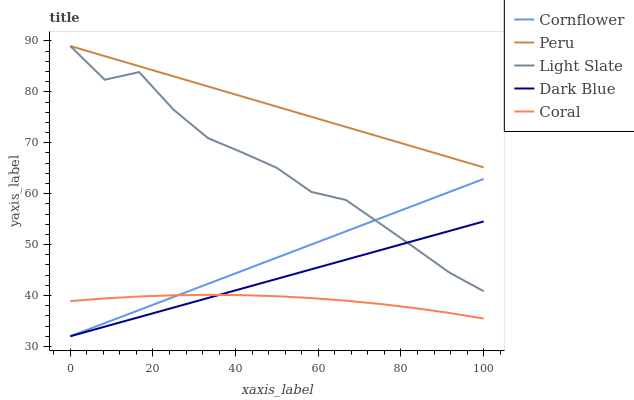Does Coral have the minimum area under the curve?
Answer yes or no. Yes. Does Peru have the maximum area under the curve?
Answer yes or no. Yes. Does Cornflower have the minimum area under the curve?
Answer yes or no. No. Does Cornflower have the maximum area under the curve?
Answer yes or no. No. Is Cornflower the smoothest?
Answer yes or no. Yes. Is Light Slate the roughest?
Answer yes or no. Yes. Is Coral the smoothest?
Answer yes or no. No. Is Coral the roughest?
Answer yes or no. No. Does Coral have the lowest value?
Answer yes or no. No. Does Peru have the highest value?
Answer yes or no. Yes. Does Cornflower have the highest value?
Answer yes or no. No. Is Coral less than Light Slate?
Answer yes or no. Yes. Is Peru greater than Dark Blue?
Answer yes or no. Yes. Does Light Slate intersect Cornflower?
Answer yes or no. Yes. Is Light Slate less than Cornflower?
Answer yes or no. No. Is Light Slate greater than Cornflower?
Answer yes or no. No. Does Coral intersect Light Slate?
Answer yes or no. No. 